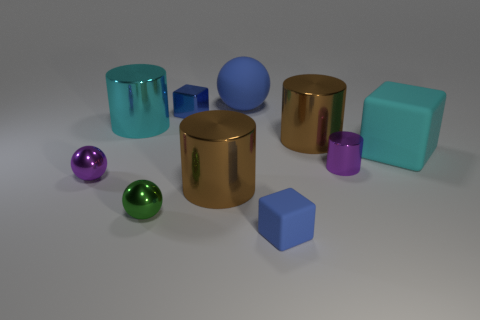Subtract all tiny cubes. How many cubes are left? 1 Subtract all big green metallic balls. Subtract all large cyan cylinders. How many objects are left? 9 Add 8 small purple shiny objects. How many small purple shiny objects are left? 10 Add 5 large cyan rubber objects. How many large cyan rubber objects exist? 6 Subtract all blue cubes. How many cubes are left? 1 Subtract 0 red spheres. How many objects are left? 10 Subtract all balls. How many objects are left? 7 Subtract 2 spheres. How many spheres are left? 1 Subtract all green spheres. Subtract all gray cylinders. How many spheres are left? 2 Subtract all yellow cubes. How many green balls are left? 1 